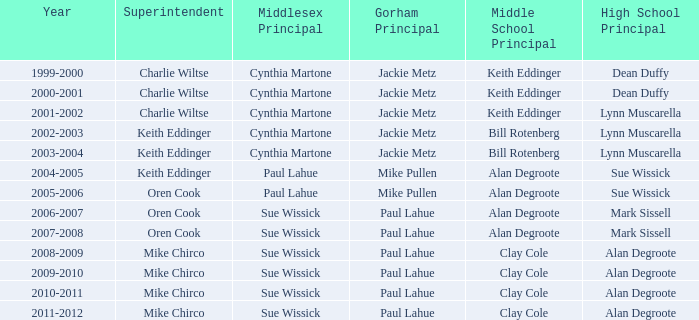How many middlesex headmasters were there in 2000-2001? 1.0. 